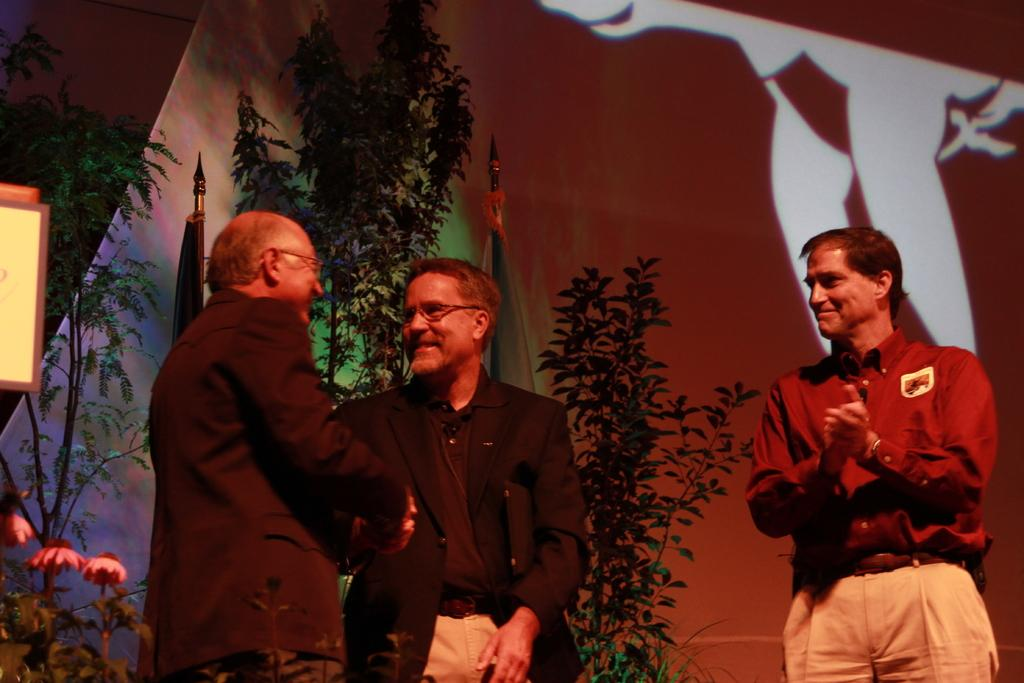What can be seen in the image? There are people standing in the image. What is visible in the background of the image? There are trees and flags in the background of the image. Can you describe any other elements in the image? Yes, there is a curtain visible in the image. What type of bead is being used to hold the curtain in the image? There is no bead present in the image; it is a curtain that is visible. What is the stomach condition of the people in the image? There is no information about the stomach condition of the people in the image. 